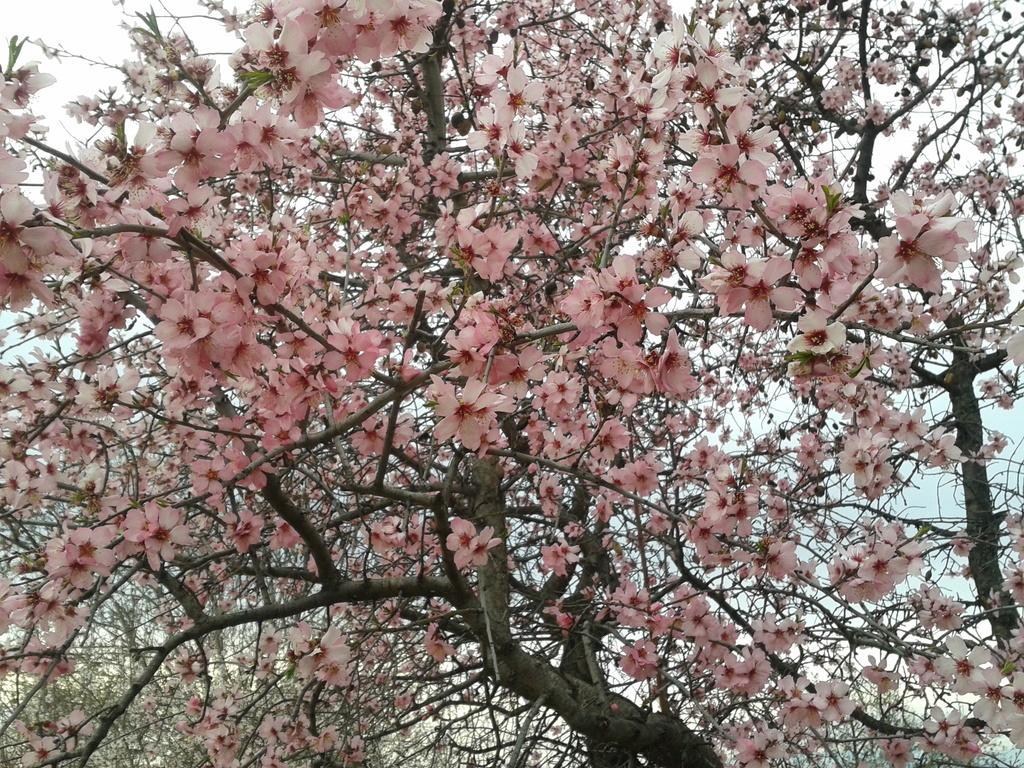In one or two sentences, can you explain what this image depicts? In this image, I can see trees with flowers. In the background there is the sky. 